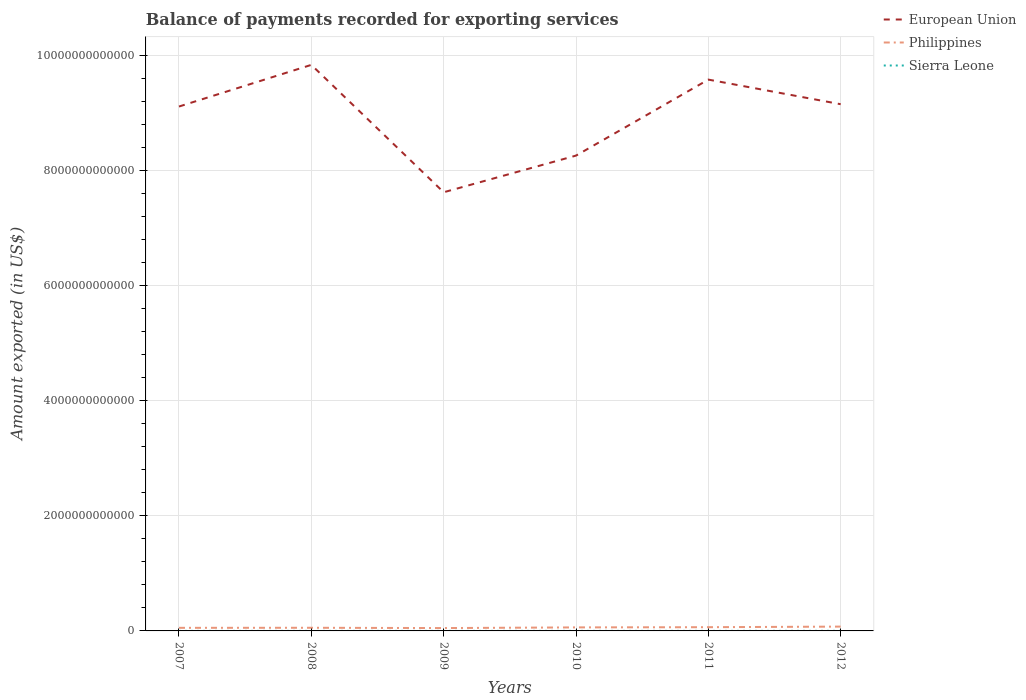Is the number of lines equal to the number of legend labels?
Make the answer very short. Yes. Across all years, what is the maximum amount exported in European Union?
Keep it short and to the point. 7.62e+12. In which year was the amount exported in Sierra Leone maximum?
Your answer should be compact. 2008. What is the total amount exported in European Union in the graph?
Offer a terse response. -1.53e+12. What is the difference between the highest and the second highest amount exported in Sierra Leone?
Give a very brief answer. 1.00e+09. How many lines are there?
Make the answer very short. 3. What is the difference between two consecutive major ticks on the Y-axis?
Your answer should be very brief. 2.00e+12. Does the graph contain any zero values?
Offer a very short reply. No. Does the graph contain grids?
Offer a very short reply. Yes. Where does the legend appear in the graph?
Give a very brief answer. Top right. How are the legend labels stacked?
Your answer should be compact. Vertical. What is the title of the graph?
Offer a very short reply. Balance of payments recorded for exporting services. What is the label or title of the X-axis?
Your answer should be compact. Years. What is the label or title of the Y-axis?
Offer a very short reply. Amount exported (in US$). What is the Amount exported (in US$) in European Union in 2007?
Offer a very short reply. 9.11e+12. What is the Amount exported (in US$) of Philippines in 2007?
Your answer should be very brief. 5.37e+1. What is the Amount exported (in US$) in Sierra Leone in 2007?
Offer a terse response. 3.74e+08. What is the Amount exported (in US$) of European Union in 2008?
Keep it short and to the point. 9.84e+12. What is the Amount exported (in US$) of Philippines in 2008?
Offer a very short reply. 5.47e+1. What is the Amount exported (in US$) of Sierra Leone in 2008?
Your answer should be very brief. 3.48e+08. What is the Amount exported (in US$) of European Union in 2009?
Ensure brevity in your answer.  7.62e+12. What is the Amount exported (in US$) of Philippines in 2009?
Your answer should be very brief. 4.96e+1. What is the Amount exported (in US$) of Sierra Leone in 2009?
Give a very brief answer. 3.80e+08. What is the Amount exported (in US$) in European Union in 2010?
Make the answer very short. 8.26e+12. What is the Amount exported (in US$) in Philippines in 2010?
Ensure brevity in your answer.  6.12e+1. What is the Amount exported (in US$) of Sierra Leone in 2010?
Ensure brevity in your answer.  4.27e+08. What is the Amount exported (in US$) in European Union in 2011?
Provide a short and direct response. 9.58e+12. What is the Amount exported (in US$) of Philippines in 2011?
Keep it short and to the point. 6.48e+1. What is the Amount exported (in US$) in Sierra Leone in 2011?
Ensure brevity in your answer.  5.48e+08. What is the Amount exported (in US$) of European Union in 2012?
Your answer should be compact. 9.15e+12. What is the Amount exported (in US$) of Philippines in 2012?
Give a very brief answer. 7.51e+1. What is the Amount exported (in US$) of Sierra Leone in 2012?
Provide a short and direct response. 1.35e+09. Across all years, what is the maximum Amount exported (in US$) of European Union?
Your answer should be compact. 9.84e+12. Across all years, what is the maximum Amount exported (in US$) of Philippines?
Your answer should be very brief. 7.51e+1. Across all years, what is the maximum Amount exported (in US$) of Sierra Leone?
Offer a very short reply. 1.35e+09. Across all years, what is the minimum Amount exported (in US$) of European Union?
Keep it short and to the point. 7.62e+12. Across all years, what is the minimum Amount exported (in US$) of Philippines?
Your response must be concise. 4.96e+1. Across all years, what is the minimum Amount exported (in US$) of Sierra Leone?
Offer a very short reply. 3.48e+08. What is the total Amount exported (in US$) in European Union in the graph?
Offer a very short reply. 5.36e+13. What is the total Amount exported (in US$) of Philippines in the graph?
Your response must be concise. 3.59e+11. What is the total Amount exported (in US$) in Sierra Leone in the graph?
Ensure brevity in your answer.  3.43e+09. What is the difference between the Amount exported (in US$) in European Union in 2007 and that in 2008?
Provide a short and direct response. -7.24e+11. What is the difference between the Amount exported (in US$) of Philippines in 2007 and that in 2008?
Give a very brief answer. -1.04e+09. What is the difference between the Amount exported (in US$) in Sierra Leone in 2007 and that in 2008?
Keep it short and to the point. 2.57e+07. What is the difference between the Amount exported (in US$) of European Union in 2007 and that in 2009?
Provide a short and direct response. 1.49e+12. What is the difference between the Amount exported (in US$) of Philippines in 2007 and that in 2009?
Your answer should be very brief. 4.06e+09. What is the difference between the Amount exported (in US$) of Sierra Leone in 2007 and that in 2009?
Offer a very short reply. -5.72e+06. What is the difference between the Amount exported (in US$) in European Union in 2007 and that in 2010?
Your response must be concise. 8.53e+11. What is the difference between the Amount exported (in US$) in Philippines in 2007 and that in 2010?
Your answer should be very brief. -7.54e+09. What is the difference between the Amount exported (in US$) of Sierra Leone in 2007 and that in 2010?
Your answer should be very brief. -5.27e+07. What is the difference between the Amount exported (in US$) of European Union in 2007 and that in 2011?
Give a very brief answer. -4.68e+11. What is the difference between the Amount exported (in US$) of Philippines in 2007 and that in 2011?
Provide a succinct answer. -1.11e+1. What is the difference between the Amount exported (in US$) in Sierra Leone in 2007 and that in 2011?
Ensure brevity in your answer.  -1.74e+08. What is the difference between the Amount exported (in US$) of European Union in 2007 and that in 2012?
Your answer should be very brief. -4.03e+1. What is the difference between the Amount exported (in US$) in Philippines in 2007 and that in 2012?
Give a very brief answer. -2.14e+1. What is the difference between the Amount exported (in US$) in Sierra Leone in 2007 and that in 2012?
Offer a very short reply. -9.76e+08. What is the difference between the Amount exported (in US$) in European Union in 2008 and that in 2009?
Offer a very short reply. 2.21e+12. What is the difference between the Amount exported (in US$) of Philippines in 2008 and that in 2009?
Give a very brief answer. 5.11e+09. What is the difference between the Amount exported (in US$) of Sierra Leone in 2008 and that in 2009?
Your response must be concise. -3.15e+07. What is the difference between the Amount exported (in US$) of European Union in 2008 and that in 2010?
Keep it short and to the point. 1.58e+12. What is the difference between the Amount exported (in US$) of Philippines in 2008 and that in 2010?
Offer a very short reply. -6.50e+09. What is the difference between the Amount exported (in US$) of Sierra Leone in 2008 and that in 2010?
Ensure brevity in your answer.  -7.84e+07. What is the difference between the Amount exported (in US$) in European Union in 2008 and that in 2011?
Your answer should be very brief. 2.56e+11. What is the difference between the Amount exported (in US$) in Philippines in 2008 and that in 2011?
Provide a short and direct response. -1.01e+1. What is the difference between the Amount exported (in US$) in Sierra Leone in 2008 and that in 2011?
Your response must be concise. -2.00e+08. What is the difference between the Amount exported (in US$) in European Union in 2008 and that in 2012?
Ensure brevity in your answer.  6.83e+11. What is the difference between the Amount exported (in US$) of Philippines in 2008 and that in 2012?
Your answer should be very brief. -2.03e+1. What is the difference between the Amount exported (in US$) of Sierra Leone in 2008 and that in 2012?
Your response must be concise. -1.00e+09. What is the difference between the Amount exported (in US$) of European Union in 2009 and that in 2010?
Offer a very short reply. -6.37e+11. What is the difference between the Amount exported (in US$) of Philippines in 2009 and that in 2010?
Make the answer very short. -1.16e+1. What is the difference between the Amount exported (in US$) in Sierra Leone in 2009 and that in 2010?
Ensure brevity in your answer.  -4.70e+07. What is the difference between the Amount exported (in US$) of European Union in 2009 and that in 2011?
Your answer should be compact. -1.96e+12. What is the difference between the Amount exported (in US$) in Philippines in 2009 and that in 2011?
Your answer should be compact. -1.52e+1. What is the difference between the Amount exported (in US$) in Sierra Leone in 2009 and that in 2011?
Make the answer very short. -1.68e+08. What is the difference between the Amount exported (in US$) in European Union in 2009 and that in 2012?
Give a very brief answer. -1.53e+12. What is the difference between the Amount exported (in US$) of Philippines in 2009 and that in 2012?
Give a very brief answer. -2.54e+1. What is the difference between the Amount exported (in US$) in Sierra Leone in 2009 and that in 2012?
Keep it short and to the point. -9.71e+08. What is the difference between the Amount exported (in US$) of European Union in 2010 and that in 2011?
Your answer should be compact. -1.32e+12. What is the difference between the Amount exported (in US$) of Philippines in 2010 and that in 2011?
Ensure brevity in your answer.  -3.55e+09. What is the difference between the Amount exported (in US$) in Sierra Leone in 2010 and that in 2011?
Offer a very short reply. -1.21e+08. What is the difference between the Amount exported (in US$) of European Union in 2010 and that in 2012?
Ensure brevity in your answer.  -8.93e+11. What is the difference between the Amount exported (in US$) in Philippines in 2010 and that in 2012?
Provide a succinct answer. -1.38e+1. What is the difference between the Amount exported (in US$) of Sierra Leone in 2010 and that in 2012?
Your answer should be compact. -9.24e+08. What is the difference between the Amount exported (in US$) of European Union in 2011 and that in 2012?
Provide a succinct answer. 4.28e+11. What is the difference between the Amount exported (in US$) of Philippines in 2011 and that in 2012?
Your answer should be very brief. -1.03e+1. What is the difference between the Amount exported (in US$) in Sierra Leone in 2011 and that in 2012?
Your answer should be compact. -8.02e+08. What is the difference between the Amount exported (in US$) of European Union in 2007 and the Amount exported (in US$) of Philippines in 2008?
Offer a very short reply. 9.06e+12. What is the difference between the Amount exported (in US$) of European Union in 2007 and the Amount exported (in US$) of Sierra Leone in 2008?
Provide a succinct answer. 9.11e+12. What is the difference between the Amount exported (in US$) of Philippines in 2007 and the Amount exported (in US$) of Sierra Leone in 2008?
Keep it short and to the point. 5.33e+1. What is the difference between the Amount exported (in US$) of European Union in 2007 and the Amount exported (in US$) of Philippines in 2009?
Ensure brevity in your answer.  9.06e+12. What is the difference between the Amount exported (in US$) in European Union in 2007 and the Amount exported (in US$) in Sierra Leone in 2009?
Offer a terse response. 9.11e+12. What is the difference between the Amount exported (in US$) in Philippines in 2007 and the Amount exported (in US$) in Sierra Leone in 2009?
Ensure brevity in your answer.  5.33e+1. What is the difference between the Amount exported (in US$) in European Union in 2007 and the Amount exported (in US$) in Philippines in 2010?
Offer a very short reply. 9.05e+12. What is the difference between the Amount exported (in US$) in European Union in 2007 and the Amount exported (in US$) in Sierra Leone in 2010?
Offer a terse response. 9.11e+12. What is the difference between the Amount exported (in US$) of Philippines in 2007 and the Amount exported (in US$) of Sierra Leone in 2010?
Make the answer very short. 5.33e+1. What is the difference between the Amount exported (in US$) of European Union in 2007 and the Amount exported (in US$) of Philippines in 2011?
Offer a terse response. 9.05e+12. What is the difference between the Amount exported (in US$) of European Union in 2007 and the Amount exported (in US$) of Sierra Leone in 2011?
Make the answer very short. 9.11e+12. What is the difference between the Amount exported (in US$) of Philippines in 2007 and the Amount exported (in US$) of Sierra Leone in 2011?
Keep it short and to the point. 5.31e+1. What is the difference between the Amount exported (in US$) in European Union in 2007 and the Amount exported (in US$) in Philippines in 2012?
Your answer should be very brief. 9.04e+12. What is the difference between the Amount exported (in US$) of European Union in 2007 and the Amount exported (in US$) of Sierra Leone in 2012?
Offer a terse response. 9.11e+12. What is the difference between the Amount exported (in US$) of Philippines in 2007 and the Amount exported (in US$) of Sierra Leone in 2012?
Provide a short and direct response. 5.23e+1. What is the difference between the Amount exported (in US$) in European Union in 2008 and the Amount exported (in US$) in Philippines in 2009?
Provide a short and direct response. 9.79e+12. What is the difference between the Amount exported (in US$) of European Union in 2008 and the Amount exported (in US$) of Sierra Leone in 2009?
Your answer should be very brief. 9.83e+12. What is the difference between the Amount exported (in US$) of Philippines in 2008 and the Amount exported (in US$) of Sierra Leone in 2009?
Give a very brief answer. 5.44e+1. What is the difference between the Amount exported (in US$) in European Union in 2008 and the Amount exported (in US$) in Philippines in 2010?
Your answer should be very brief. 9.77e+12. What is the difference between the Amount exported (in US$) of European Union in 2008 and the Amount exported (in US$) of Sierra Leone in 2010?
Offer a terse response. 9.83e+12. What is the difference between the Amount exported (in US$) in Philippines in 2008 and the Amount exported (in US$) in Sierra Leone in 2010?
Provide a succinct answer. 5.43e+1. What is the difference between the Amount exported (in US$) in European Union in 2008 and the Amount exported (in US$) in Philippines in 2011?
Provide a succinct answer. 9.77e+12. What is the difference between the Amount exported (in US$) of European Union in 2008 and the Amount exported (in US$) of Sierra Leone in 2011?
Offer a very short reply. 9.83e+12. What is the difference between the Amount exported (in US$) in Philippines in 2008 and the Amount exported (in US$) in Sierra Leone in 2011?
Your answer should be compact. 5.42e+1. What is the difference between the Amount exported (in US$) in European Union in 2008 and the Amount exported (in US$) in Philippines in 2012?
Your response must be concise. 9.76e+12. What is the difference between the Amount exported (in US$) of European Union in 2008 and the Amount exported (in US$) of Sierra Leone in 2012?
Your answer should be very brief. 9.83e+12. What is the difference between the Amount exported (in US$) in Philippines in 2008 and the Amount exported (in US$) in Sierra Leone in 2012?
Keep it short and to the point. 5.34e+1. What is the difference between the Amount exported (in US$) in European Union in 2009 and the Amount exported (in US$) in Philippines in 2010?
Your answer should be compact. 7.56e+12. What is the difference between the Amount exported (in US$) of European Union in 2009 and the Amount exported (in US$) of Sierra Leone in 2010?
Ensure brevity in your answer.  7.62e+12. What is the difference between the Amount exported (in US$) of Philippines in 2009 and the Amount exported (in US$) of Sierra Leone in 2010?
Your response must be concise. 4.92e+1. What is the difference between the Amount exported (in US$) of European Union in 2009 and the Amount exported (in US$) of Philippines in 2011?
Your answer should be compact. 7.56e+12. What is the difference between the Amount exported (in US$) in European Union in 2009 and the Amount exported (in US$) in Sierra Leone in 2011?
Keep it short and to the point. 7.62e+12. What is the difference between the Amount exported (in US$) in Philippines in 2009 and the Amount exported (in US$) in Sierra Leone in 2011?
Keep it short and to the point. 4.91e+1. What is the difference between the Amount exported (in US$) of European Union in 2009 and the Amount exported (in US$) of Philippines in 2012?
Give a very brief answer. 7.55e+12. What is the difference between the Amount exported (in US$) of European Union in 2009 and the Amount exported (in US$) of Sierra Leone in 2012?
Make the answer very short. 7.62e+12. What is the difference between the Amount exported (in US$) of Philippines in 2009 and the Amount exported (in US$) of Sierra Leone in 2012?
Your answer should be very brief. 4.83e+1. What is the difference between the Amount exported (in US$) of European Union in 2010 and the Amount exported (in US$) of Philippines in 2011?
Your answer should be very brief. 8.19e+12. What is the difference between the Amount exported (in US$) in European Union in 2010 and the Amount exported (in US$) in Sierra Leone in 2011?
Give a very brief answer. 8.26e+12. What is the difference between the Amount exported (in US$) in Philippines in 2010 and the Amount exported (in US$) in Sierra Leone in 2011?
Provide a succinct answer. 6.07e+1. What is the difference between the Amount exported (in US$) of European Union in 2010 and the Amount exported (in US$) of Philippines in 2012?
Your answer should be very brief. 8.18e+12. What is the difference between the Amount exported (in US$) in European Union in 2010 and the Amount exported (in US$) in Sierra Leone in 2012?
Keep it short and to the point. 8.26e+12. What is the difference between the Amount exported (in US$) in Philippines in 2010 and the Amount exported (in US$) in Sierra Leone in 2012?
Ensure brevity in your answer.  5.99e+1. What is the difference between the Amount exported (in US$) in European Union in 2011 and the Amount exported (in US$) in Philippines in 2012?
Ensure brevity in your answer.  9.50e+12. What is the difference between the Amount exported (in US$) in European Union in 2011 and the Amount exported (in US$) in Sierra Leone in 2012?
Give a very brief answer. 9.58e+12. What is the difference between the Amount exported (in US$) of Philippines in 2011 and the Amount exported (in US$) of Sierra Leone in 2012?
Make the answer very short. 6.34e+1. What is the average Amount exported (in US$) in European Union per year?
Offer a terse response. 8.93e+12. What is the average Amount exported (in US$) in Philippines per year?
Your answer should be compact. 5.99e+1. What is the average Amount exported (in US$) of Sierra Leone per year?
Ensure brevity in your answer.  5.71e+08. In the year 2007, what is the difference between the Amount exported (in US$) of European Union and Amount exported (in US$) of Philippines?
Your response must be concise. 9.06e+12. In the year 2007, what is the difference between the Amount exported (in US$) of European Union and Amount exported (in US$) of Sierra Leone?
Provide a short and direct response. 9.11e+12. In the year 2007, what is the difference between the Amount exported (in US$) in Philippines and Amount exported (in US$) in Sierra Leone?
Your answer should be compact. 5.33e+1. In the year 2008, what is the difference between the Amount exported (in US$) in European Union and Amount exported (in US$) in Philippines?
Give a very brief answer. 9.78e+12. In the year 2008, what is the difference between the Amount exported (in US$) of European Union and Amount exported (in US$) of Sierra Leone?
Your answer should be very brief. 9.83e+12. In the year 2008, what is the difference between the Amount exported (in US$) in Philippines and Amount exported (in US$) in Sierra Leone?
Your answer should be very brief. 5.44e+1. In the year 2009, what is the difference between the Amount exported (in US$) in European Union and Amount exported (in US$) in Philippines?
Provide a short and direct response. 7.57e+12. In the year 2009, what is the difference between the Amount exported (in US$) in European Union and Amount exported (in US$) in Sierra Leone?
Give a very brief answer. 7.62e+12. In the year 2009, what is the difference between the Amount exported (in US$) of Philippines and Amount exported (in US$) of Sierra Leone?
Offer a terse response. 4.93e+1. In the year 2010, what is the difference between the Amount exported (in US$) of European Union and Amount exported (in US$) of Philippines?
Ensure brevity in your answer.  8.20e+12. In the year 2010, what is the difference between the Amount exported (in US$) in European Union and Amount exported (in US$) in Sierra Leone?
Offer a terse response. 8.26e+12. In the year 2010, what is the difference between the Amount exported (in US$) of Philippines and Amount exported (in US$) of Sierra Leone?
Ensure brevity in your answer.  6.08e+1. In the year 2011, what is the difference between the Amount exported (in US$) in European Union and Amount exported (in US$) in Philippines?
Make the answer very short. 9.51e+12. In the year 2011, what is the difference between the Amount exported (in US$) in European Union and Amount exported (in US$) in Sierra Leone?
Ensure brevity in your answer.  9.58e+12. In the year 2011, what is the difference between the Amount exported (in US$) in Philippines and Amount exported (in US$) in Sierra Leone?
Offer a very short reply. 6.42e+1. In the year 2012, what is the difference between the Amount exported (in US$) in European Union and Amount exported (in US$) in Philippines?
Provide a succinct answer. 9.08e+12. In the year 2012, what is the difference between the Amount exported (in US$) of European Union and Amount exported (in US$) of Sierra Leone?
Offer a very short reply. 9.15e+12. In the year 2012, what is the difference between the Amount exported (in US$) of Philippines and Amount exported (in US$) of Sierra Leone?
Provide a succinct answer. 7.37e+1. What is the ratio of the Amount exported (in US$) of European Union in 2007 to that in 2008?
Provide a short and direct response. 0.93. What is the ratio of the Amount exported (in US$) of Sierra Leone in 2007 to that in 2008?
Your response must be concise. 1.07. What is the ratio of the Amount exported (in US$) of European Union in 2007 to that in 2009?
Your response must be concise. 1.2. What is the ratio of the Amount exported (in US$) in Philippines in 2007 to that in 2009?
Make the answer very short. 1.08. What is the ratio of the Amount exported (in US$) of Sierra Leone in 2007 to that in 2009?
Provide a short and direct response. 0.98. What is the ratio of the Amount exported (in US$) in European Union in 2007 to that in 2010?
Your answer should be compact. 1.1. What is the ratio of the Amount exported (in US$) in Philippines in 2007 to that in 2010?
Provide a succinct answer. 0.88. What is the ratio of the Amount exported (in US$) in Sierra Leone in 2007 to that in 2010?
Offer a very short reply. 0.88. What is the ratio of the Amount exported (in US$) in European Union in 2007 to that in 2011?
Provide a succinct answer. 0.95. What is the ratio of the Amount exported (in US$) in Philippines in 2007 to that in 2011?
Provide a short and direct response. 0.83. What is the ratio of the Amount exported (in US$) of Sierra Leone in 2007 to that in 2011?
Keep it short and to the point. 0.68. What is the ratio of the Amount exported (in US$) of Philippines in 2007 to that in 2012?
Your response must be concise. 0.72. What is the ratio of the Amount exported (in US$) in Sierra Leone in 2007 to that in 2012?
Give a very brief answer. 0.28. What is the ratio of the Amount exported (in US$) of European Union in 2008 to that in 2009?
Ensure brevity in your answer.  1.29. What is the ratio of the Amount exported (in US$) of Philippines in 2008 to that in 2009?
Offer a terse response. 1.1. What is the ratio of the Amount exported (in US$) in Sierra Leone in 2008 to that in 2009?
Offer a terse response. 0.92. What is the ratio of the Amount exported (in US$) of European Union in 2008 to that in 2010?
Your answer should be compact. 1.19. What is the ratio of the Amount exported (in US$) of Philippines in 2008 to that in 2010?
Make the answer very short. 0.89. What is the ratio of the Amount exported (in US$) in Sierra Leone in 2008 to that in 2010?
Offer a terse response. 0.82. What is the ratio of the Amount exported (in US$) of European Union in 2008 to that in 2011?
Your answer should be compact. 1.03. What is the ratio of the Amount exported (in US$) of Philippines in 2008 to that in 2011?
Your answer should be very brief. 0.84. What is the ratio of the Amount exported (in US$) in Sierra Leone in 2008 to that in 2011?
Provide a short and direct response. 0.64. What is the ratio of the Amount exported (in US$) of European Union in 2008 to that in 2012?
Give a very brief answer. 1.07. What is the ratio of the Amount exported (in US$) in Philippines in 2008 to that in 2012?
Offer a very short reply. 0.73. What is the ratio of the Amount exported (in US$) in Sierra Leone in 2008 to that in 2012?
Provide a short and direct response. 0.26. What is the ratio of the Amount exported (in US$) of European Union in 2009 to that in 2010?
Your answer should be very brief. 0.92. What is the ratio of the Amount exported (in US$) in Philippines in 2009 to that in 2010?
Your answer should be compact. 0.81. What is the ratio of the Amount exported (in US$) in Sierra Leone in 2009 to that in 2010?
Provide a short and direct response. 0.89. What is the ratio of the Amount exported (in US$) in European Union in 2009 to that in 2011?
Make the answer very short. 0.8. What is the ratio of the Amount exported (in US$) of Philippines in 2009 to that in 2011?
Provide a short and direct response. 0.77. What is the ratio of the Amount exported (in US$) in Sierra Leone in 2009 to that in 2011?
Your response must be concise. 0.69. What is the ratio of the Amount exported (in US$) of European Union in 2009 to that in 2012?
Offer a terse response. 0.83. What is the ratio of the Amount exported (in US$) of Philippines in 2009 to that in 2012?
Provide a short and direct response. 0.66. What is the ratio of the Amount exported (in US$) of Sierra Leone in 2009 to that in 2012?
Ensure brevity in your answer.  0.28. What is the ratio of the Amount exported (in US$) of European Union in 2010 to that in 2011?
Your answer should be very brief. 0.86. What is the ratio of the Amount exported (in US$) of Philippines in 2010 to that in 2011?
Provide a succinct answer. 0.95. What is the ratio of the Amount exported (in US$) in Sierra Leone in 2010 to that in 2011?
Offer a terse response. 0.78. What is the ratio of the Amount exported (in US$) of European Union in 2010 to that in 2012?
Ensure brevity in your answer.  0.9. What is the ratio of the Amount exported (in US$) of Philippines in 2010 to that in 2012?
Offer a very short reply. 0.82. What is the ratio of the Amount exported (in US$) in Sierra Leone in 2010 to that in 2012?
Your response must be concise. 0.32. What is the ratio of the Amount exported (in US$) of European Union in 2011 to that in 2012?
Keep it short and to the point. 1.05. What is the ratio of the Amount exported (in US$) of Philippines in 2011 to that in 2012?
Give a very brief answer. 0.86. What is the ratio of the Amount exported (in US$) in Sierra Leone in 2011 to that in 2012?
Make the answer very short. 0.41. What is the difference between the highest and the second highest Amount exported (in US$) in European Union?
Provide a short and direct response. 2.56e+11. What is the difference between the highest and the second highest Amount exported (in US$) of Philippines?
Keep it short and to the point. 1.03e+1. What is the difference between the highest and the second highest Amount exported (in US$) of Sierra Leone?
Make the answer very short. 8.02e+08. What is the difference between the highest and the lowest Amount exported (in US$) of European Union?
Keep it short and to the point. 2.21e+12. What is the difference between the highest and the lowest Amount exported (in US$) in Philippines?
Offer a very short reply. 2.54e+1. What is the difference between the highest and the lowest Amount exported (in US$) of Sierra Leone?
Your response must be concise. 1.00e+09. 